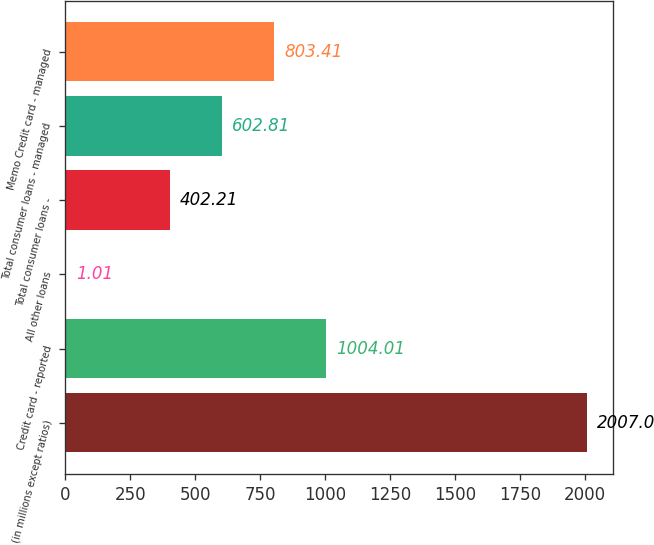Convert chart to OTSL. <chart><loc_0><loc_0><loc_500><loc_500><bar_chart><fcel>(in millions except ratios)<fcel>Credit card - reported<fcel>All other loans<fcel>Total consumer loans -<fcel>Total consumer loans - managed<fcel>Memo Credit card - managed<nl><fcel>2007<fcel>1004.01<fcel>1.01<fcel>402.21<fcel>602.81<fcel>803.41<nl></chart> 